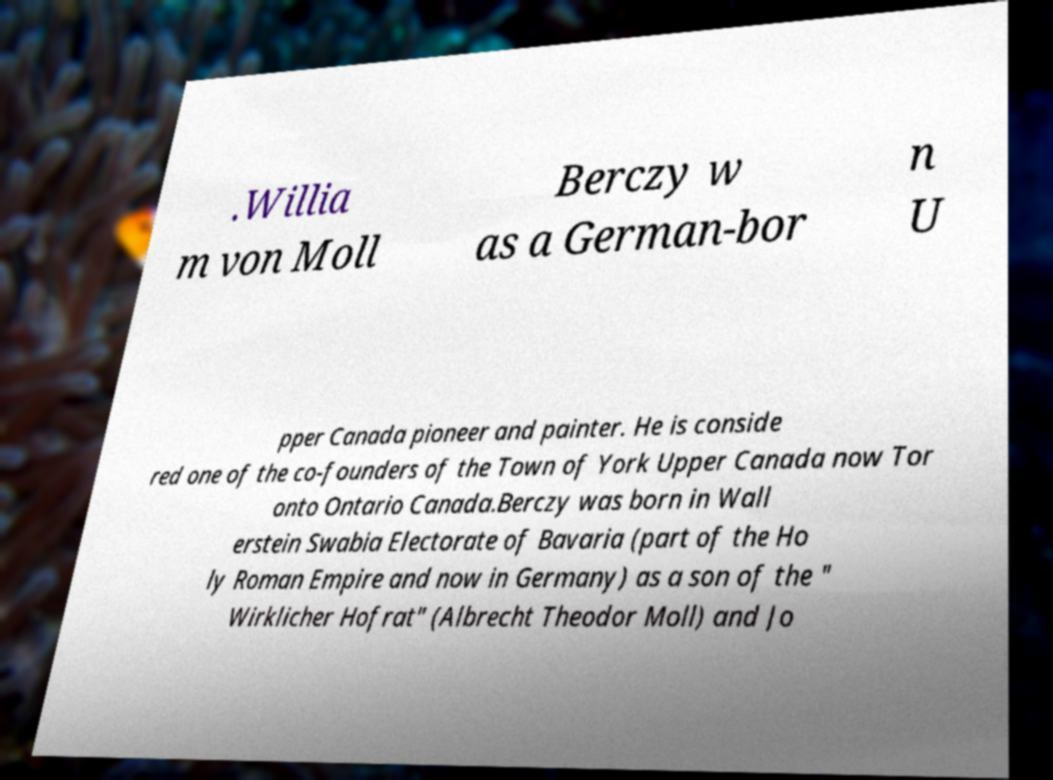There's text embedded in this image that I need extracted. Can you transcribe it verbatim? .Willia m von Moll Berczy w as a German-bor n U pper Canada pioneer and painter. He is conside red one of the co-founders of the Town of York Upper Canada now Tor onto Ontario Canada.Berczy was born in Wall erstein Swabia Electorate of Bavaria (part of the Ho ly Roman Empire and now in Germany) as a son of the " Wirklicher Hofrat" (Albrecht Theodor Moll) and Jo 